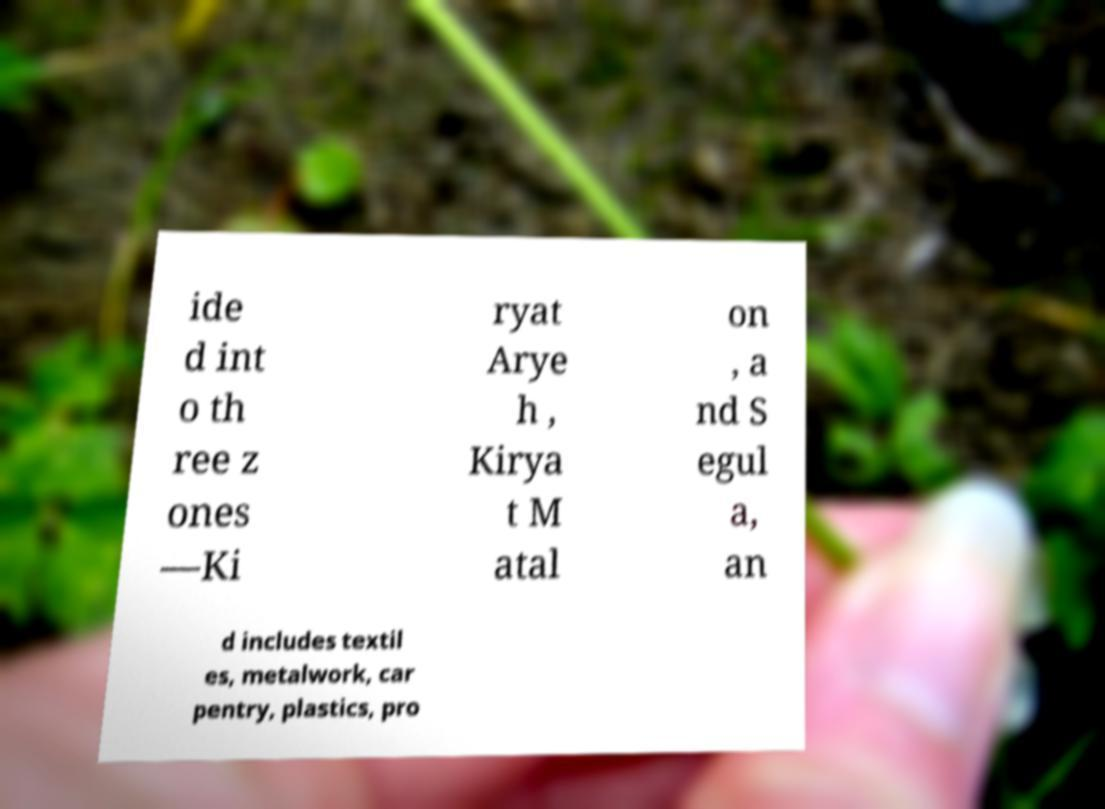I need the written content from this picture converted into text. Can you do that? ide d int o th ree z ones —Ki ryat Arye h , Kirya t M atal on , a nd S egul a, an d includes textil es, metalwork, car pentry, plastics, pro 